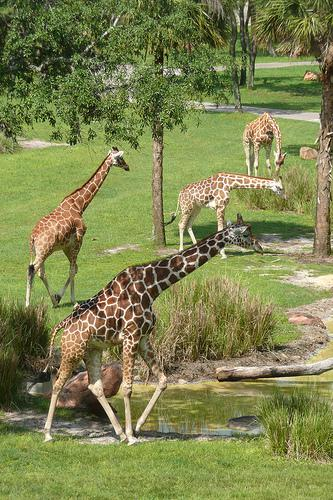Question: how many giraffes are visible?
Choices:
A. 1.
B. 4.
C. 2.
D. 3.
Answer with the letter. Answer: B Question: where was this picture likely taken?
Choices:
A. Zoo.
B. Beach.
C. Forest.
D. Backyard.
Answer with the letter. Answer: A Question: who is in the picture?
Choices:
A. No one.
B. 1 person.
C. 2 people.
D. Children.
Answer with the letter. Answer: A Question: what are the animals in the picture?
Choices:
A. Zebras.
B. Elephants.
C. Dogs.
D. Giraffes.
Answer with the letter. Answer: D Question: what direction is the closest giraffe headed?
Choices:
A. Left.
B. Right.
C. Forward.
D. Backward.
Answer with the letter. Answer: B 